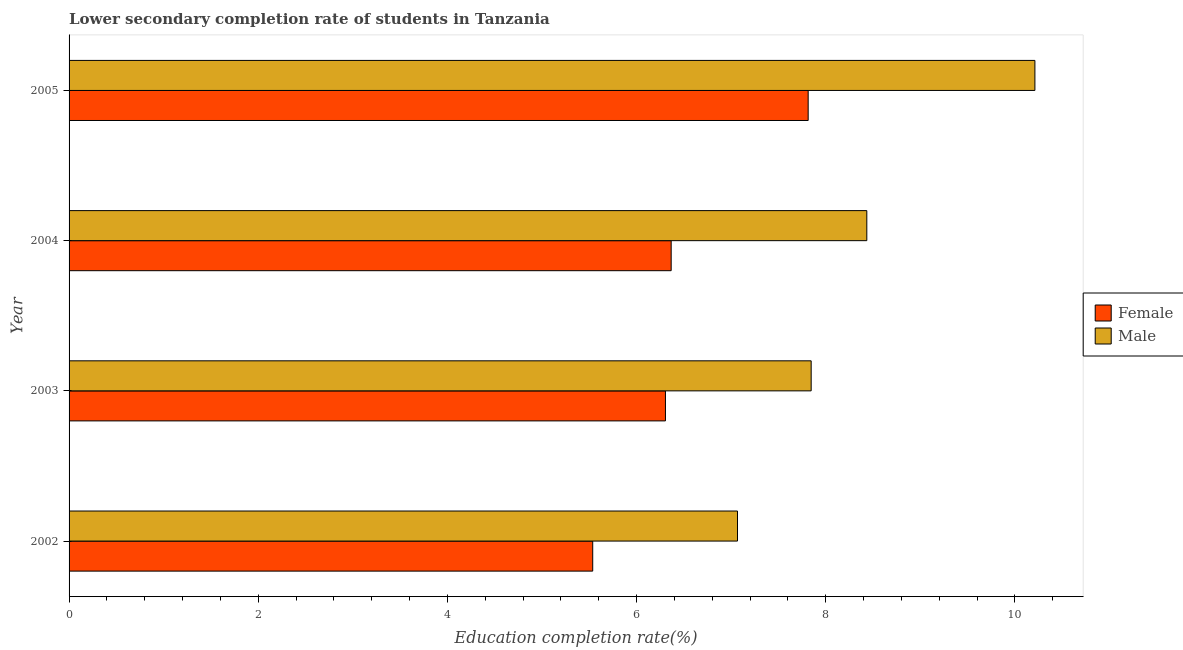How many groups of bars are there?
Ensure brevity in your answer.  4. Are the number of bars on each tick of the Y-axis equal?
Offer a very short reply. Yes. In how many cases, is the number of bars for a given year not equal to the number of legend labels?
Make the answer very short. 0. What is the education completion rate of female students in 2004?
Offer a very short reply. 6.37. Across all years, what is the maximum education completion rate of male students?
Offer a very short reply. 10.21. Across all years, what is the minimum education completion rate of female students?
Your answer should be very brief. 5.54. What is the total education completion rate of male students in the graph?
Offer a terse response. 33.56. What is the difference between the education completion rate of female students in 2004 and that in 2005?
Make the answer very short. -1.45. What is the difference between the education completion rate of female students in 2005 and the education completion rate of male students in 2003?
Provide a short and direct response. -0.03. What is the average education completion rate of female students per year?
Offer a terse response. 6.51. In the year 2005, what is the difference between the education completion rate of female students and education completion rate of male students?
Provide a succinct answer. -2.4. In how many years, is the education completion rate of female students greater than 2.8 %?
Your response must be concise. 4. What is the ratio of the education completion rate of female students in 2004 to that in 2005?
Your answer should be very brief. 0.81. What is the difference between the highest and the second highest education completion rate of male students?
Keep it short and to the point. 1.78. What is the difference between the highest and the lowest education completion rate of female students?
Ensure brevity in your answer.  2.28. What does the 2nd bar from the top in 2003 represents?
Your answer should be very brief. Female. What does the 2nd bar from the bottom in 2002 represents?
Make the answer very short. Male. How many bars are there?
Provide a short and direct response. 8. Are all the bars in the graph horizontal?
Your answer should be very brief. Yes. How many years are there in the graph?
Make the answer very short. 4. Does the graph contain grids?
Ensure brevity in your answer.  No. Where does the legend appear in the graph?
Make the answer very short. Center right. How many legend labels are there?
Offer a terse response. 2. What is the title of the graph?
Provide a short and direct response. Lower secondary completion rate of students in Tanzania. Does "Measles" appear as one of the legend labels in the graph?
Make the answer very short. No. What is the label or title of the X-axis?
Keep it short and to the point. Education completion rate(%). What is the Education completion rate(%) of Female in 2002?
Your answer should be very brief. 5.54. What is the Education completion rate(%) of Male in 2002?
Offer a terse response. 7.07. What is the Education completion rate(%) in Female in 2003?
Give a very brief answer. 6.31. What is the Education completion rate(%) of Male in 2003?
Keep it short and to the point. 7.85. What is the Education completion rate(%) of Female in 2004?
Keep it short and to the point. 6.37. What is the Education completion rate(%) in Male in 2004?
Keep it short and to the point. 8.43. What is the Education completion rate(%) in Female in 2005?
Give a very brief answer. 7.81. What is the Education completion rate(%) of Male in 2005?
Offer a terse response. 10.21. Across all years, what is the maximum Education completion rate(%) of Female?
Provide a short and direct response. 7.81. Across all years, what is the maximum Education completion rate(%) of Male?
Keep it short and to the point. 10.21. Across all years, what is the minimum Education completion rate(%) of Female?
Your answer should be compact. 5.54. Across all years, what is the minimum Education completion rate(%) in Male?
Your answer should be compact. 7.07. What is the total Education completion rate(%) of Female in the graph?
Offer a very short reply. 26.02. What is the total Education completion rate(%) of Male in the graph?
Provide a succinct answer. 33.56. What is the difference between the Education completion rate(%) in Female in 2002 and that in 2003?
Offer a very short reply. -0.77. What is the difference between the Education completion rate(%) in Male in 2002 and that in 2003?
Keep it short and to the point. -0.78. What is the difference between the Education completion rate(%) of Female in 2002 and that in 2004?
Provide a short and direct response. -0.83. What is the difference between the Education completion rate(%) of Male in 2002 and that in 2004?
Offer a very short reply. -1.37. What is the difference between the Education completion rate(%) of Female in 2002 and that in 2005?
Your answer should be very brief. -2.28. What is the difference between the Education completion rate(%) in Male in 2002 and that in 2005?
Provide a short and direct response. -3.14. What is the difference between the Education completion rate(%) of Female in 2003 and that in 2004?
Offer a very short reply. -0.06. What is the difference between the Education completion rate(%) of Male in 2003 and that in 2004?
Give a very brief answer. -0.59. What is the difference between the Education completion rate(%) in Female in 2003 and that in 2005?
Your answer should be compact. -1.51. What is the difference between the Education completion rate(%) in Male in 2003 and that in 2005?
Your response must be concise. -2.37. What is the difference between the Education completion rate(%) of Female in 2004 and that in 2005?
Your answer should be very brief. -1.45. What is the difference between the Education completion rate(%) in Male in 2004 and that in 2005?
Make the answer very short. -1.78. What is the difference between the Education completion rate(%) in Female in 2002 and the Education completion rate(%) in Male in 2003?
Your response must be concise. -2.31. What is the difference between the Education completion rate(%) of Female in 2002 and the Education completion rate(%) of Male in 2004?
Provide a succinct answer. -2.9. What is the difference between the Education completion rate(%) of Female in 2002 and the Education completion rate(%) of Male in 2005?
Provide a short and direct response. -4.68. What is the difference between the Education completion rate(%) in Female in 2003 and the Education completion rate(%) in Male in 2004?
Your response must be concise. -2.13. What is the difference between the Education completion rate(%) in Female in 2003 and the Education completion rate(%) in Male in 2005?
Make the answer very short. -3.91. What is the difference between the Education completion rate(%) in Female in 2004 and the Education completion rate(%) in Male in 2005?
Offer a terse response. -3.85. What is the average Education completion rate(%) of Female per year?
Keep it short and to the point. 6.51. What is the average Education completion rate(%) in Male per year?
Your answer should be very brief. 8.39. In the year 2002, what is the difference between the Education completion rate(%) of Female and Education completion rate(%) of Male?
Make the answer very short. -1.53. In the year 2003, what is the difference between the Education completion rate(%) in Female and Education completion rate(%) in Male?
Keep it short and to the point. -1.54. In the year 2004, what is the difference between the Education completion rate(%) in Female and Education completion rate(%) in Male?
Provide a short and direct response. -2.07. In the year 2005, what is the difference between the Education completion rate(%) of Female and Education completion rate(%) of Male?
Your answer should be very brief. -2.4. What is the ratio of the Education completion rate(%) in Female in 2002 to that in 2003?
Ensure brevity in your answer.  0.88. What is the ratio of the Education completion rate(%) of Male in 2002 to that in 2003?
Your answer should be compact. 0.9. What is the ratio of the Education completion rate(%) in Female in 2002 to that in 2004?
Provide a short and direct response. 0.87. What is the ratio of the Education completion rate(%) in Male in 2002 to that in 2004?
Provide a short and direct response. 0.84. What is the ratio of the Education completion rate(%) in Female in 2002 to that in 2005?
Your response must be concise. 0.71. What is the ratio of the Education completion rate(%) in Male in 2002 to that in 2005?
Provide a succinct answer. 0.69. What is the ratio of the Education completion rate(%) of Male in 2003 to that in 2004?
Offer a terse response. 0.93. What is the ratio of the Education completion rate(%) in Female in 2003 to that in 2005?
Offer a very short reply. 0.81. What is the ratio of the Education completion rate(%) in Male in 2003 to that in 2005?
Offer a very short reply. 0.77. What is the ratio of the Education completion rate(%) in Female in 2004 to that in 2005?
Your answer should be compact. 0.81. What is the ratio of the Education completion rate(%) in Male in 2004 to that in 2005?
Offer a very short reply. 0.83. What is the difference between the highest and the second highest Education completion rate(%) in Female?
Your response must be concise. 1.45. What is the difference between the highest and the second highest Education completion rate(%) in Male?
Offer a terse response. 1.78. What is the difference between the highest and the lowest Education completion rate(%) in Female?
Your answer should be very brief. 2.28. What is the difference between the highest and the lowest Education completion rate(%) of Male?
Your answer should be very brief. 3.14. 